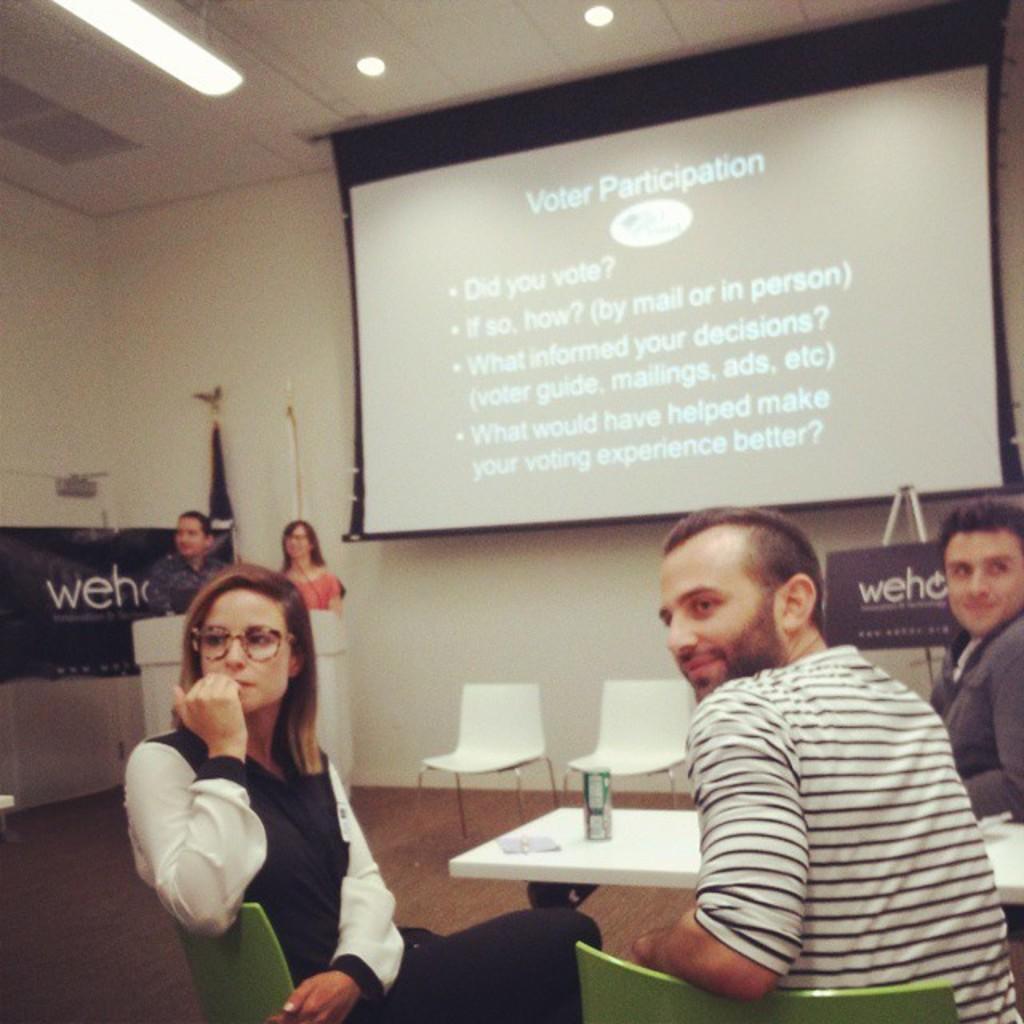In one or two sentences, can you explain what this image depicts? It is a conference room,some people are sitting around a table and behind them there is a projector. In front of the projector two people are standing in front of another table and in the background there is a wall. 